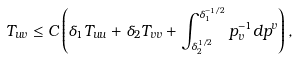Convert formula to latex. <formula><loc_0><loc_0><loc_500><loc_500>T _ { u v } \leq C \left ( \delta _ { 1 } T _ { u u } + \delta _ { 2 } T _ { v v } + \int _ { \delta _ { 2 } ^ { 1 / 2 } } ^ { \delta _ { 1 } ^ { - 1 / 2 } } p _ { v } ^ { - 1 } d p ^ { v } \right ) ,</formula> 